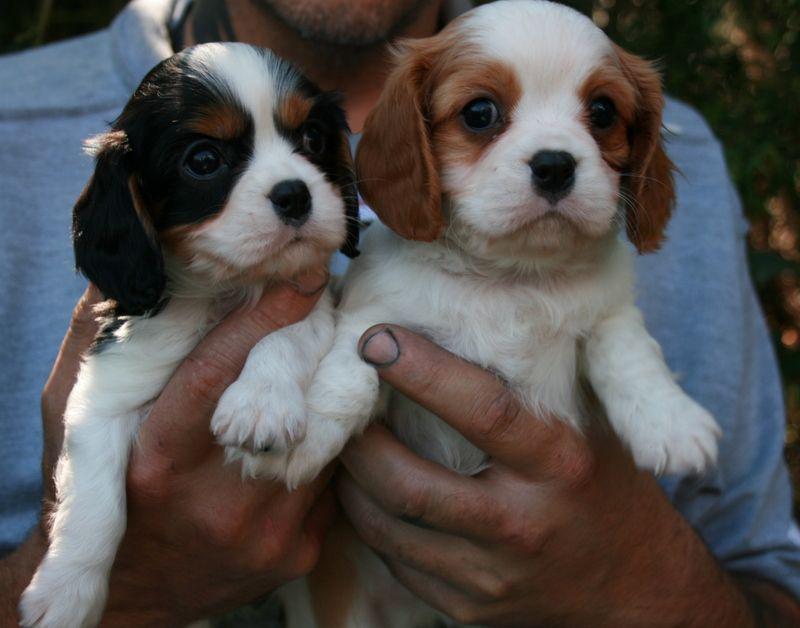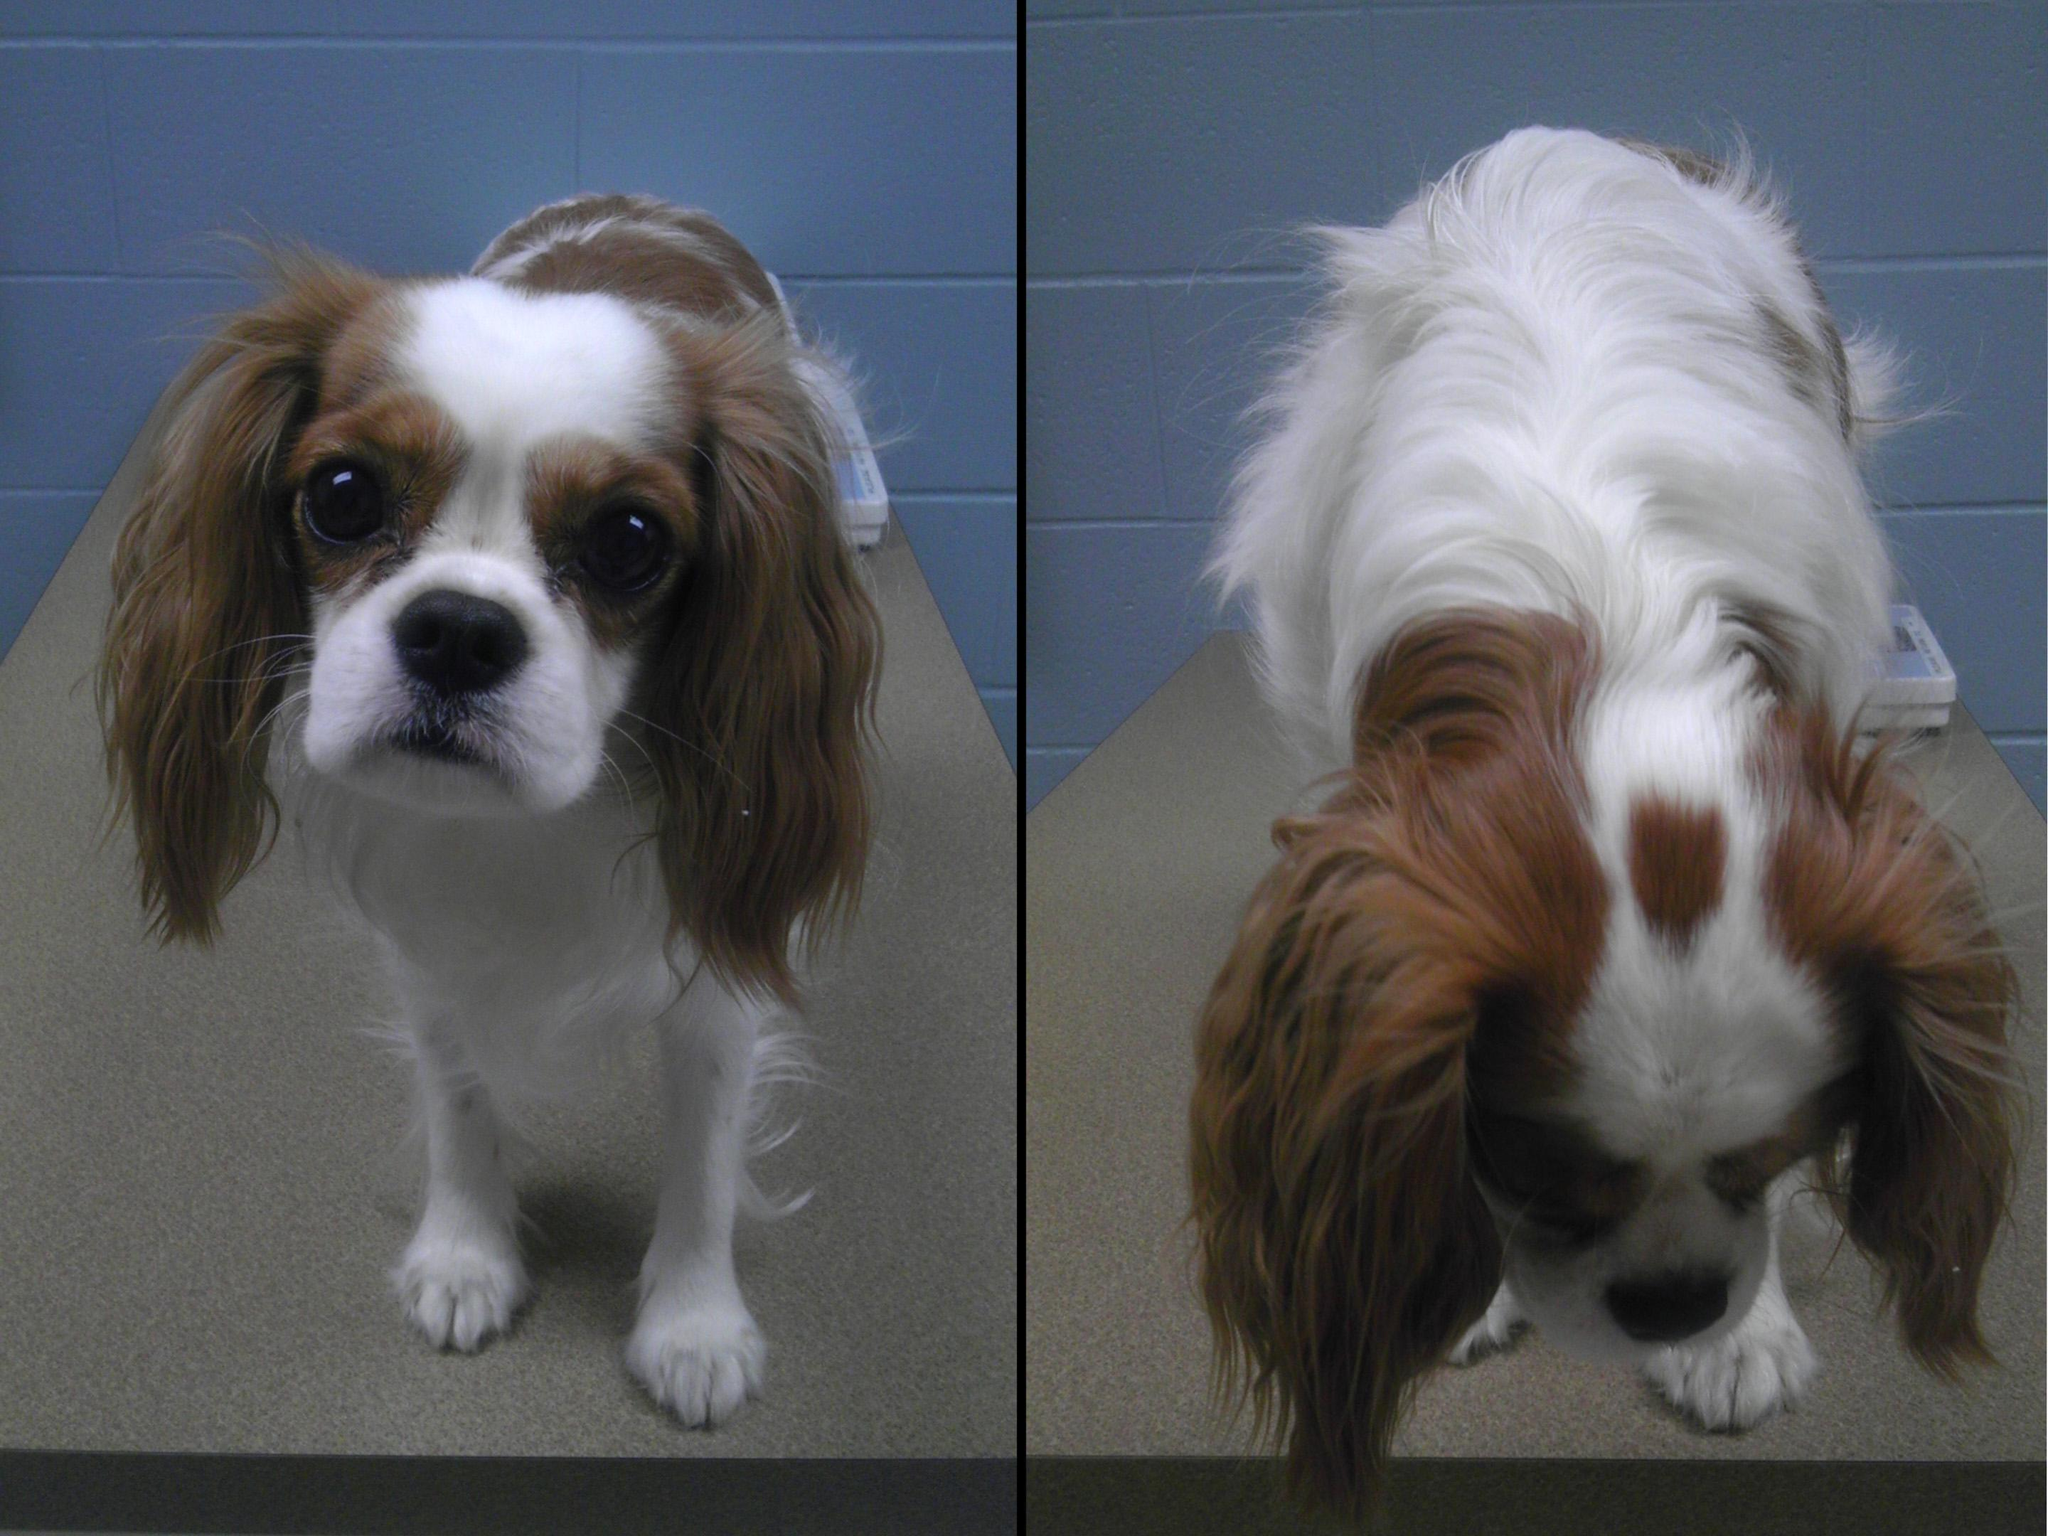The first image is the image on the left, the second image is the image on the right. Considering the images on both sides, is "An image contains a dog attached to a leash." valid? Answer yes or no. No. The first image is the image on the left, the second image is the image on the right. Assess this claim about the two images: "Right and left images contain the same number of spaniels, and all dogs are turned mostly frontward.". Correct or not? Answer yes or no. Yes. 